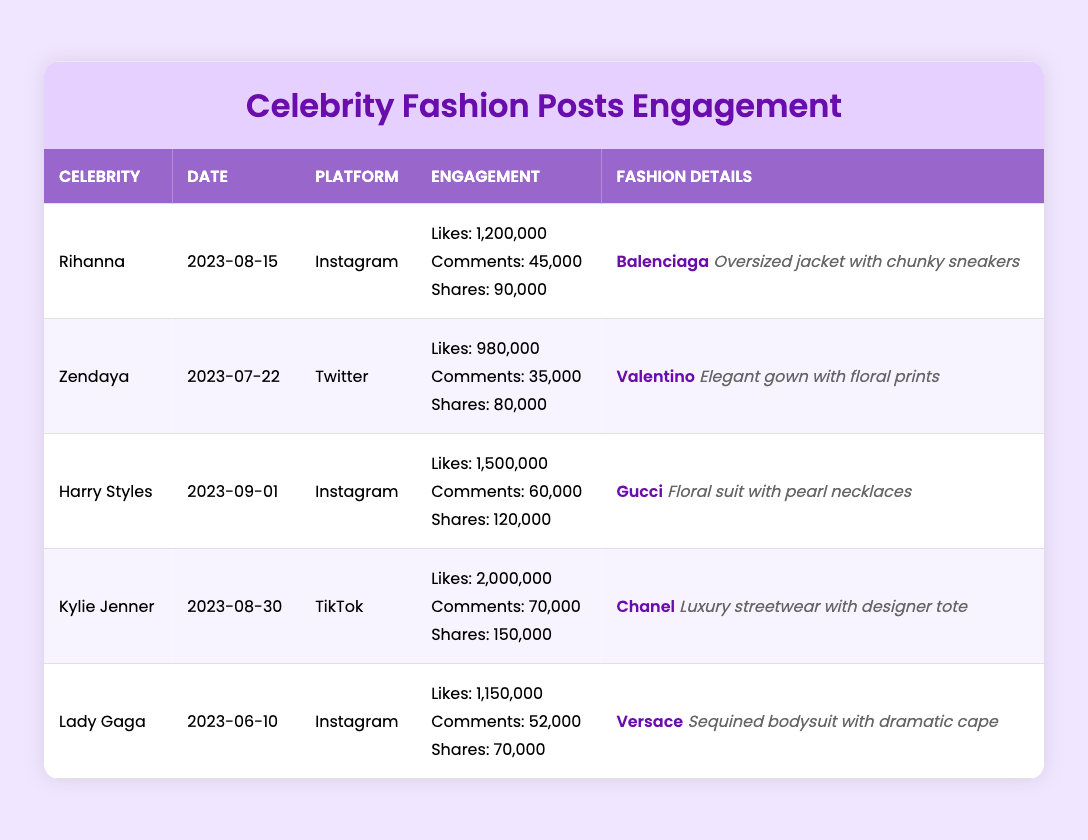What is the highest number of likes received on a celebrity fashion post? The table shows the number of likes for each celebrity post. The highest number of likes is for Kylie Jenner with 2,000,000 likes on TikTok.
Answer: 2,000,000 Which platform had the most engagements in total? To find the total engagements, we consider likes, comments, and shares separately and sum them for each platform. For Instagram, Rihanna had (1,200,000 + 45,000 + 90,000 = 1,335,000) and Lady Gaga had (1,150,000 + 52,000 + 70,000 = 1,272,000) = 2,607,000 total engagements. For TikTok, Kylie Jenner had (2,000,000 + 70,000 + 150,000 = 2,220,000). For Twitter, Zendaya had (980,000 + 35,000 + 80,000 = 1,095,000). Thus, Instagram is the highest with 2,607,000 engagements.
Answer: Instagram How many comments did Lady Gaga receive on her fashion post? The table shows that Lady Gaga received 52,000 comments on her Instagram post.
Answer: 52,000 Is Harry Styles the only celebrity to post on Instagram? A lookup of the table shows two celebrities, Rihanna and Lady Gaga, have also posted on Instagram. Therefore, Harry Styles is not the only one.
Answer: No What is the average number of shares across all celebrity fashion posts? The shares for each post are: Rihanna (90,000), Zendaya (80,000), Harry Styles (120,000), Kylie Jenner (150,000), and Lady Gaga (70,000). Summing these gives 90,000 + 80,000 + 120,000 + 150,000 + 70,000 = 510,000. There are 5 posts total, so the average shares = 510,000 / 5 = 102,000.
Answer: 102,000 